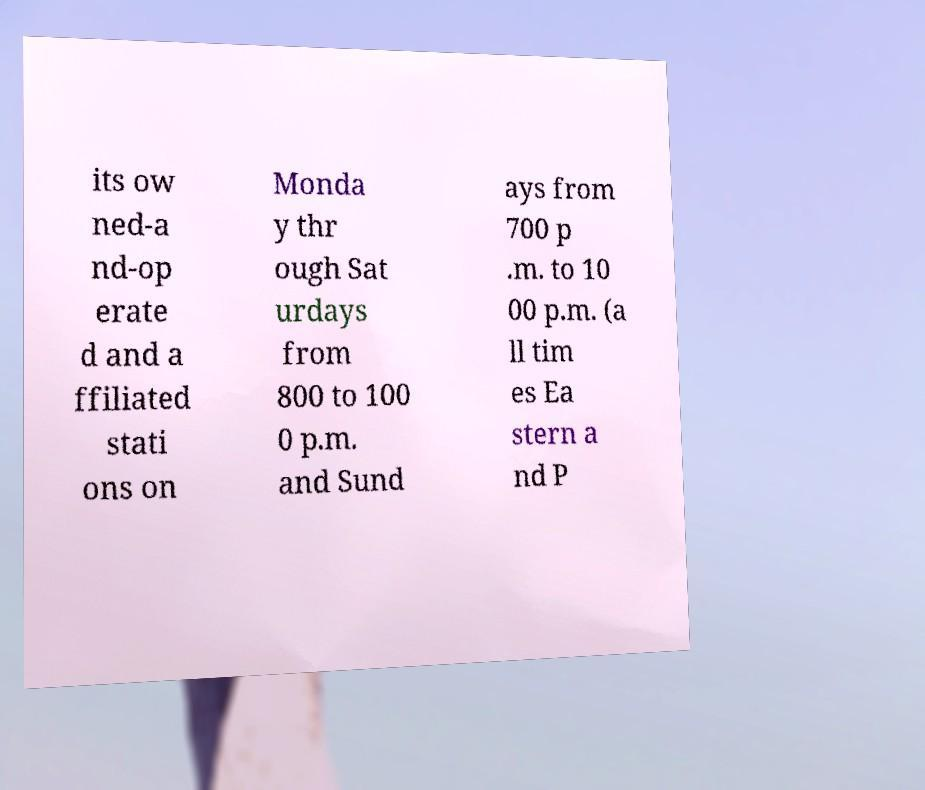Please identify and transcribe the text found in this image. its ow ned-a nd-op erate d and a ffiliated stati ons on Monda y thr ough Sat urdays from 800 to 100 0 p.m. and Sund ays from 700 p .m. to 10 00 p.m. (a ll tim es Ea stern a nd P 